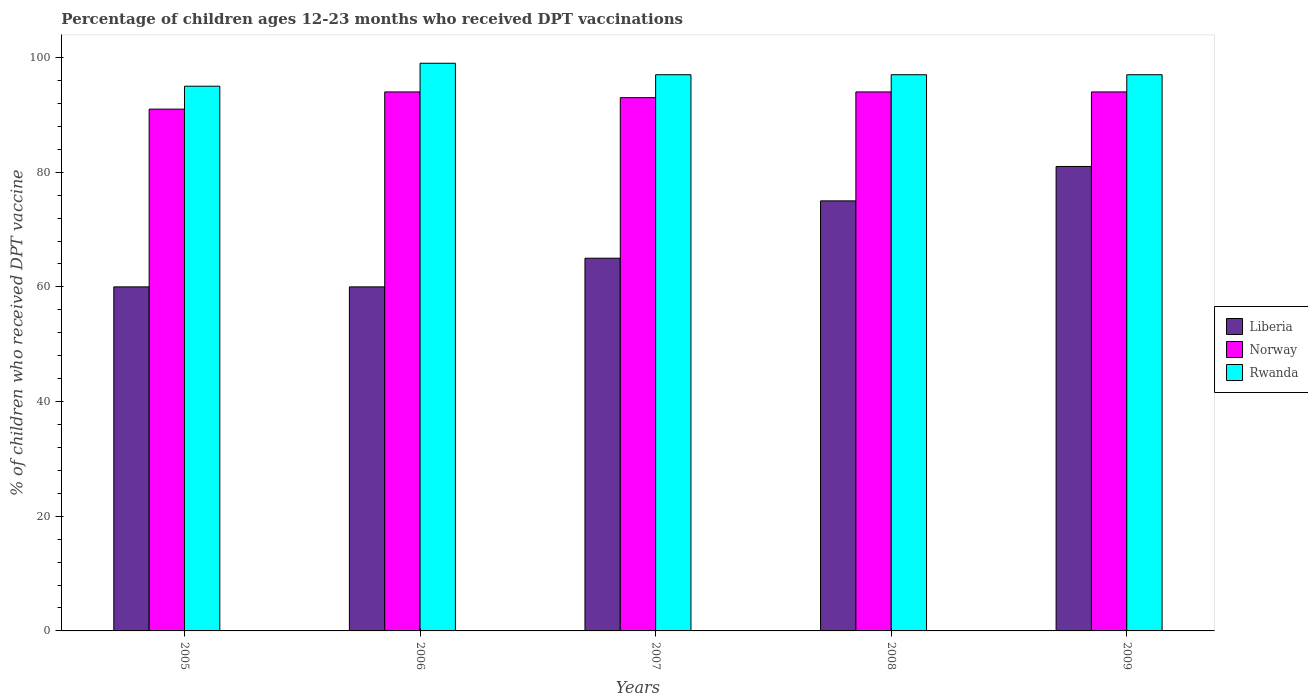Are the number of bars per tick equal to the number of legend labels?
Keep it short and to the point. Yes. How many bars are there on the 1st tick from the left?
Ensure brevity in your answer.  3. In how many cases, is the number of bars for a given year not equal to the number of legend labels?
Make the answer very short. 0. What is the percentage of children who received DPT vaccination in Norway in 2006?
Make the answer very short. 94. Across all years, what is the maximum percentage of children who received DPT vaccination in Rwanda?
Make the answer very short. 99. In which year was the percentage of children who received DPT vaccination in Liberia maximum?
Keep it short and to the point. 2009. What is the total percentage of children who received DPT vaccination in Liberia in the graph?
Give a very brief answer. 341. What is the difference between the percentage of children who received DPT vaccination in Norway in 2007 and that in 2009?
Ensure brevity in your answer.  -1. What is the difference between the percentage of children who received DPT vaccination in Norway in 2007 and the percentage of children who received DPT vaccination in Rwanda in 2009?
Your answer should be very brief. -4. What is the average percentage of children who received DPT vaccination in Norway per year?
Offer a very short reply. 93.2. In the year 2008, what is the difference between the percentage of children who received DPT vaccination in Norway and percentage of children who received DPT vaccination in Liberia?
Offer a very short reply. 19. What is the ratio of the percentage of children who received DPT vaccination in Rwanda in 2005 to that in 2006?
Your answer should be very brief. 0.96. Is the percentage of children who received DPT vaccination in Rwanda in 2005 less than that in 2009?
Ensure brevity in your answer.  Yes. What is the difference between the highest and the lowest percentage of children who received DPT vaccination in Rwanda?
Keep it short and to the point. 4. What does the 1st bar from the left in 2006 represents?
Keep it short and to the point. Liberia. What does the 1st bar from the right in 2007 represents?
Provide a succinct answer. Rwanda. Is it the case that in every year, the sum of the percentage of children who received DPT vaccination in Rwanda and percentage of children who received DPT vaccination in Liberia is greater than the percentage of children who received DPT vaccination in Norway?
Offer a very short reply. Yes. How many years are there in the graph?
Give a very brief answer. 5. What is the difference between two consecutive major ticks on the Y-axis?
Give a very brief answer. 20. Does the graph contain any zero values?
Your response must be concise. No. How many legend labels are there?
Your answer should be very brief. 3. What is the title of the graph?
Offer a terse response. Percentage of children ages 12-23 months who received DPT vaccinations. What is the label or title of the X-axis?
Offer a very short reply. Years. What is the label or title of the Y-axis?
Make the answer very short. % of children who received DPT vaccine. What is the % of children who received DPT vaccine in Liberia in 2005?
Your answer should be very brief. 60. What is the % of children who received DPT vaccine of Norway in 2005?
Keep it short and to the point. 91. What is the % of children who received DPT vaccine of Norway in 2006?
Give a very brief answer. 94. What is the % of children who received DPT vaccine of Liberia in 2007?
Your answer should be very brief. 65. What is the % of children who received DPT vaccine of Norway in 2007?
Ensure brevity in your answer.  93. What is the % of children who received DPT vaccine of Rwanda in 2007?
Make the answer very short. 97. What is the % of children who received DPT vaccine of Norway in 2008?
Offer a very short reply. 94. What is the % of children who received DPT vaccine of Rwanda in 2008?
Ensure brevity in your answer.  97. What is the % of children who received DPT vaccine in Norway in 2009?
Your answer should be compact. 94. What is the % of children who received DPT vaccine of Rwanda in 2009?
Make the answer very short. 97. Across all years, what is the maximum % of children who received DPT vaccine in Norway?
Your answer should be compact. 94. Across all years, what is the minimum % of children who received DPT vaccine in Norway?
Your response must be concise. 91. Across all years, what is the minimum % of children who received DPT vaccine in Rwanda?
Offer a terse response. 95. What is the total % of children who received DPT vaccine of Liberia in the graph?
Offer a terse response. 341. What is the total % of children who received DPT vaccine of Norway in the graph?
Ensure brevity in your answer.  466. What is the total % of children who received DPT vaccine of Rwanda in the graph?
Keep it short and to the point. 485. What is the difference between the % of children who received DPT vaccine of Liberia in 2005 and that in 2006?
Give a very brief answer. 0. What is the difference between the % of children who received DPT vaccine of Rwanda in 2005 and that in 2006?
Keep it short and to the point. -4. What is the difference between the % of children who received DPT vaccine of Liberia in 2005 and that in 2007?
Your answer should be very brief. -5. What is the difference between the % of children who received DPT vaccine of Rwanda in 2005 and that in 2007?
Keep it short and to the point. -2. What is the difference between the % of children who received DPT vaccine in Norway in 2005 and that in 2009?
Provide a short and direct response. -3. What is the difference between the % of children who received DPT vaccine in Liberia in 2006 and that in 2008?
Provide a succinct answer. -15. What is the difference between the % of children who received DPT vaccine of Norway in 2006 and that in 2008?
Offer a terse response. 0. What is the difference between the % of children who received DPT vaccine in Rwanda in 2006 and that in 2008?
Give a very brief answer. 2. What is the difference between the % of children who received DPT vaccine in Liberia in 2006 and that in 2009?
Keep it short and to the point. -21. What is the difference between the % of children who received DPT vaccine in Norway in 2006 and that in 2009?
Your answer should be very brief. 0. What is the difference between the % of children who received DPT vaccine of Liberia in 2007 and that in 2008?
Make the answer very short. -10. What is the difference between the % of children who received DPT vaccine of Norway in 2007 and that in 2008?
Provide a short and direct response. -1. What is the difference between the % of children who received DPT vaccine of Liberia in 2007 and that in 2009?
Ensure brevity in your answer.  -16. What is the difference between the % of children who received DPT vaccine in Liberia in 2008 and that in 2009?
Keep it short and to the point. -6. What is the difference between the % of children who received DPT vaccine of Rwanda in 2008 and that in 2009?
Your answer should be compact. 0. What is the difference between the % of children who received DPT vaccine in Liberia in 2005 and the % of children who received DPT vaccine in Norway in 2006?
Offer a terse response. -34. What is the difference between the % of children who received DPT vaccine in Liberia in 2005 and the % of children who received DPT vaccine in Rwanda in 2006?
Your answer should be very brief. -39. What is the difference between the % of children who received DPT vaccine in Norway in 2005 and the % of children who received DPT vaccine in Rwanda in 2006?
Give a very brief answer. -8. What is the difference between the % of children who received DPT vaccine in Liberia in 2005 and the % of children who received DPT vaccine in Norway in 2007?
Your answer should be compact. -33. What is the difference between the % of children who received DPT vaccine in Liberia in 2005 and the % of children who received DPT vaccine in Rwanda in 2007?
Keep it short and to the point. -37. What is the difference between the % of children who received DPT vaccine in Norway in 2005 and the % of children who received DPT vaccine in Rwanda in 2007?
Give a very brief answer. -6. What is the difference between the % of children who received DPT vaccine of Liberia in 2005 and the % of children who received DPT vaccine of Norway in 2008?
Your answer should be compact. -34. What is the difference between the % of children who received DPT vaccine of Liberia in 2005 and the % of children who received DPT vaccine of Rwanda in 2008?
Your answer should be compact. -37. What is the difference between the % of children who received DPT vaccine of Liberia in 2005 and the % of children who received DPT vaccine of Norway in 2009?
Your answer should be very brief. -34. What is the difference between the % of children who received DPT vaccine of Liberia in 2005 and the % of children who received DPT vaccine of Rwanda in 2009?
Offer a terse response. -37. What is the difference between the % of children who received DPT vaccine in Liberia in 2006 and the % of children who received DPT vaccine in Norway in 2007?
Keep it short and to the point. -33. What is the difference between the % of children who received DPT vaccine in Liberia in 2006 and the % of children who received DPT vaccine in Rwanda in 2007?
Make the answer very short. -37. What is the difference between the % of children who received DPT vaccine in Liberia in 2006 and the % of children who received DPT vaccine in Norway in 2008?
Offer a very short reply. -34. What is the difference between the % of children who received DPT vaccine in Liberia in 2006 and the % of children who received DPT vaccine in Rwanda in 2008?
Give a very brief answer. -37. What is the difference between the % of children who received DPT vaccine of Norway in 2006 and the % of children who received DPT vaccine of Rwanda in 2008?
Your response must be concise. -3. What is the difference between the % of children who received DPT vaccine in Liberia in 2006 and the % of children who received DPT vaccine in Norway in 2009?
Give a very brief answer. -34. What is the difference between the % of children who received DPT vaccine of Liberia in 2006 and the % of children who received DPT vaccine of Rwanda in 2009?
Offer a terse response. -37. What is the difference between the % of children who received DPT vaccine of Norway in 2006 and the % of children who received DPT vaccine of Rwanda in 2009?
Your response must be concise. -3. What is the difference between the % of children who received DPT vaccine in Liberia in 2007 and the % of children who received DPT vaccine in Norway in 2008?
Provide a succinct answer. -29. What is the difference between the % of children who received DPT vaccine in Liberia in 2007 and the % of children who received DPT vaccine in Rwanda in 2008?
Make the answer very short. -32. What is the difference between the % of children who received DPT vaccine of Norway in 2007 and the % of children who received DPT vaccine of Rwanda in 2008?
Offer a terse response. -4. What is the difference between the % of children who received DPT vaccine of Liberia in 2007 and the % of children who received DPT vaccine of Rwanda in 2009?
Ensure brevity in your answer.  -32. What is the difference between the % of children who received DPT vaccine of Norway in 2007 and the % of children who received DPT vaccine of Rwanda in 2009?
Your answer should be very brief. -4. What is the difference between the % of children who received DPT vaccine of Liberia in 2008 and the % of children who received DPT vaccine of Rwanda in 2009?
Offer a very short reply. -22. What is the difference between the % of children who received DPT vaccine in Norway in 2008 and the % of children who received DPT vaccine in Rwanda in 2009?
Your answer should be very brief. -3. What is the average % of children who received DPT vaccine in Liberia per year?
Keep it short and to the point. 68.2. What is the average % of children who received DPT vaccine of Norway per year?
Keep it short and to the point. 93.2. What is the average % of children who received DPT vaccine in Rwanda per year?
Keep it short and to the point. 97. In the year 2005, what is the difference between the % of children who received DPT vaccine of Liberia and % of children who received DPT vaccine of Norway?
Offer a terse response. -31. In the year 2005, what is the difference between the % of children who received DPT vaccine in Liberia and % of children who received DPT vaccine in Rwanda?
Your answer should be very brief. -35. In the year 2005, what is the difference between the % of children who received DPT vaccine of Norway and % of children who received DPT vaccine of Rwanda?
Ensure brevity in your answer.  -4. In the year 2006, what is the difference between the % of children who received DPT vaccine in Liberia and % of children who received DPT vaccine in Norway?
Provide a succinct answer. -34. In the year 2006, what is the difference between the % of children who received DPT vaccine of Liberia and % of children who received DPT vaccine of Rwanda?
Offer a very short reply. -39. In the year 2007, what is the difference between the % of children who received DPT vaccine in Liberia and % of children who received DPT vaccine in Rwanda?
Your answer should be compact. -32. In the year 2008, what is the difference between the % of children who received DPT vaccine of Liberia and % of children who received DPT vaccine of Norway?
Ensure brevity in your answer.  -19. In the year 2008, what is the difference between the % of children who received DPT vaccine of Liberia and % of children who received DPT vaccine of Rwanda?
Provide a succinct answer. -22. In the year 2009, what is the difference between the % of children who received DPT vaccine in Liberia and % of children who received DPT vaccine in Rwanda?
Ensure brevity in your answer.  -16. In the year 2009, what is the difference between the % of children who received DPT vaccine of Norway and % of children who received DPT vaccine of Rwanda?
Provide a succinct answer. -3. What is the ratio of the % of children who received DPT vaccine of Norway in 2005 to that in 2006?
Provide a succinct answer. 0.97. What is the ratio of the % of children who received DPT vaccine in Rwanda in 2005 to that in 2006?
Offer a terse response. 0.96. What is the ratio of the % of children who received DPT vaccine in Norway in 2005 to that in 2007?
Offer a very short reply. 0.98. What is the ratio of the % of children who received DPT vaccine in Rwanda in 2005 to that in 2007?
Keep it short and to the point. 0.98. What is the ratio of the % of children who received DPT vaccine in Norway in 2005 to that in 2008?
Offer a very short reply. 0.97. What is the ratio of the % of children who received DPT vaccine in Rwanda in 2005 to that in 2008?
Ensure brevity in your answer.  0.98. What is the ratio of the % of children who received DPT vaccine in Liberia in 2005 to that in 2009?
Your answer should be very brief. 0.74. What is the ratio of the % of children who received DPT vaccine in Norway in 2005 to that in 2009?
Provide a short and direct response. 0.97. What is the ratio of the % of children who received DPT vaccine in Rwanda in 2005 to that in 2009?
Your answer should be compact. 0.98. What is the ratio of the % of children who received DPT vaccine of Liberia in 2006 to that in 2007?
Your answer should be compact. 0.92. What is the ratio of the % of children who received DPT vaccine of Norway in 2006 to that in 2007?
Offer a very short reply. 1.01. What is the ratio of the % of children who received DPT vaccine in Rwanda in 2006 to that in 2007?
Give a very brief answer. 1.02. What is the ratio of the % of children who received DPT vaccine in Norway in 2006 to that in 2008?
Your answer should be very brief. 1. What is the ratio of the % of children who received DPT vaccine of Rwanda in 2006 to that in 2008?
Give a very brief answer. 1.02. What is the ratio of the % of children who received DPT vaccine in Liberia in 2006 to that in 2009?
Offer a terse response. 0.74. What is the ratio of the % of children who received DPT vaccine of Rwanda in 2006 to that in 2009?
Keep it short and to the point. 1.02. What is the ratio of the % of children who received DPT vaccine in Liberia in 2007 to that in 2008?
Keep it short and to the point. 0.87. What is the ratio of the % of children who received DPT vaccine in Norway in 2007 to that in 2008?
Keep it short and to the point. 0.99. What is the ratio of the % of children who received DPT vaccine of Rwanda in 2007 to that in 2008?
Provide a succinct answer. 1. What is the ratio of the % of children who received DPT vaccine of Liberia in 2007 to that in 2009?
Offer a terse response. 0.8. What is the ratio of the % of children who received DPT vaccine of Liberia in 2008 to that in 2009?
Your answer should be compact. 0.93. What is the ratio of the % of children who received DPT vaccine of Norway in 2008 to that in 2009?
Provide a succinct answer. 1. What is the ratio of the % of children who received DPT vaccine of Rwanda in 2008 to that in 2009?
Make the answer very short. 1. What is the difference between the highest and the second highest % of children who received DPT vaccine in Liberia?
Offer a very short reply. 6. What is the difference between the highest and the second highest % of children who received DPT vaccine in Rwanda?
Your answer should be very brief. 2. 